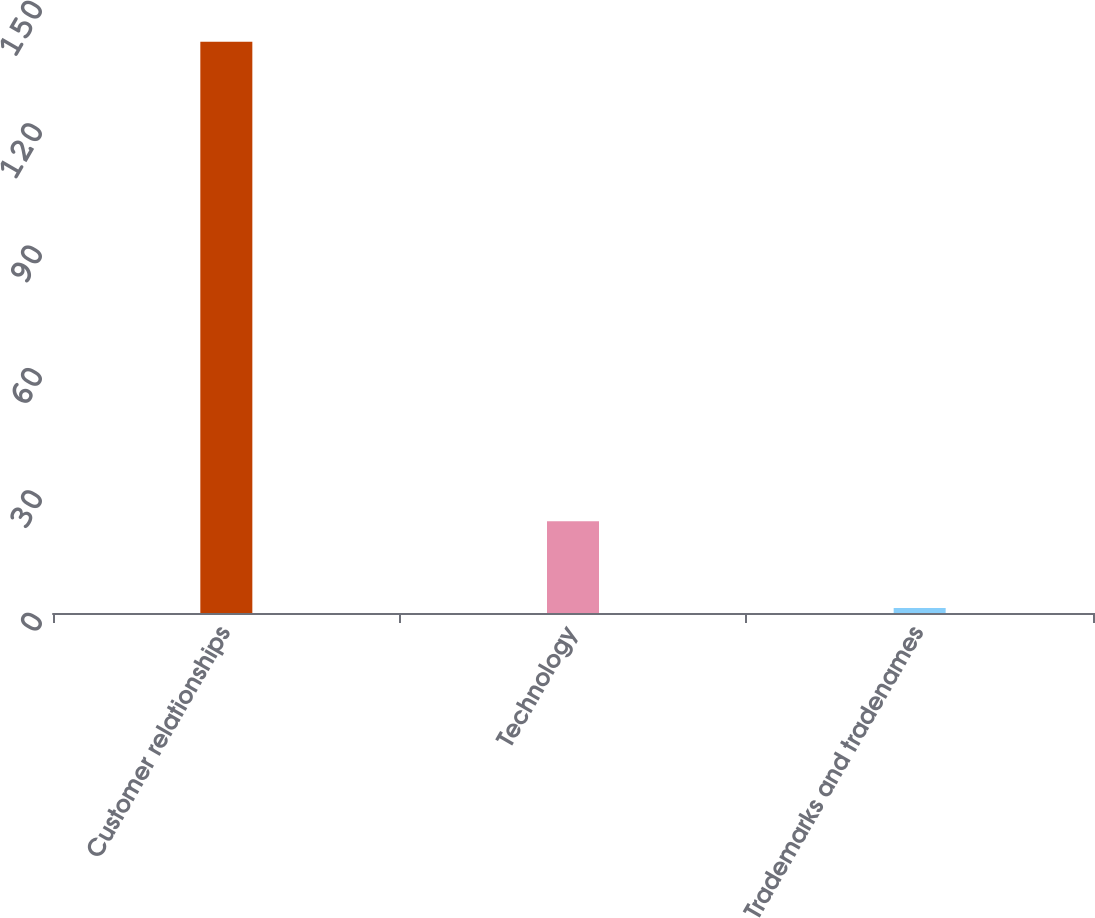Convert chart. <chart><loc_0><loc_0><loc_500><loc_500><bar_chart><fcel>Customer relationships<fcel>Technology<fcel>Trademarks and tradenames<nl><fcel>140<fcel>22.5<fcel>1.2<nl></chart> 